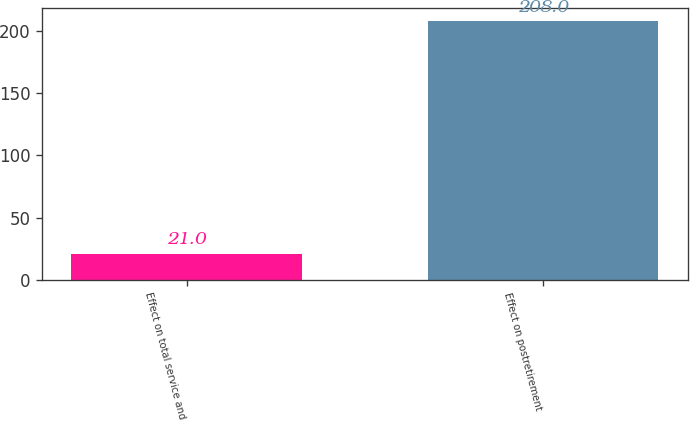<chart> <loc_0><loc_0><loc_500><loc_500><bar_chart><fcel>Effect on total service and<fcel>Effect on postretirement<nl><fcel>21<fcel>208<nl></chart> 